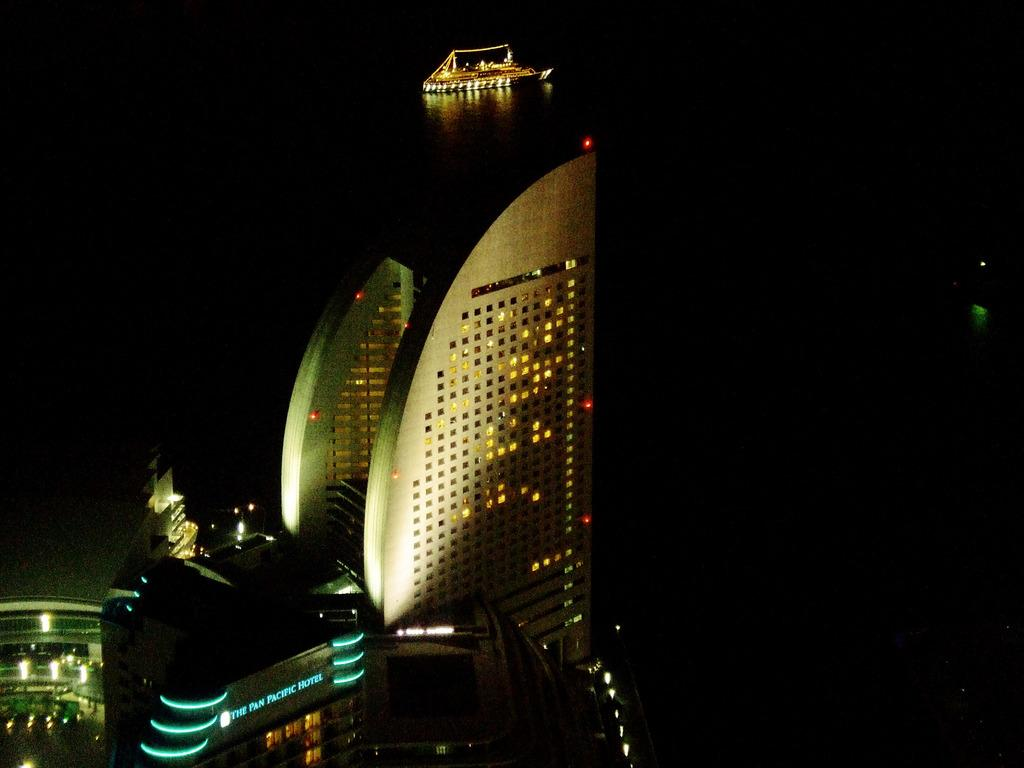<image>
Share a concise interpretation of the image provided. The Pan Pacific Hotel is seen lit up at night. 